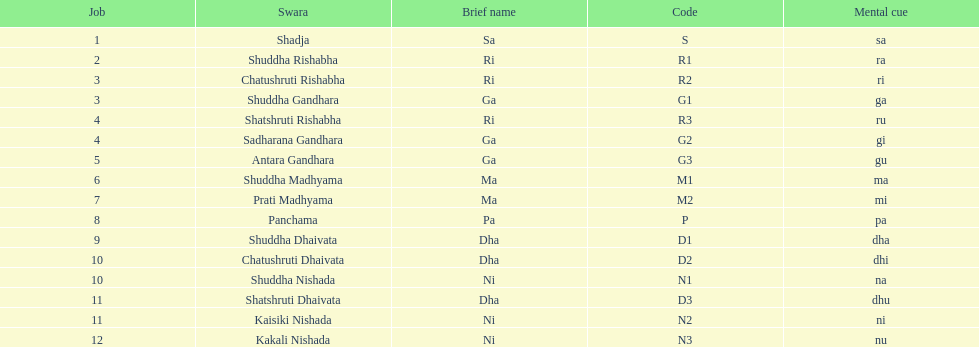Find the 9th position swara. what is its short name? Dha. 